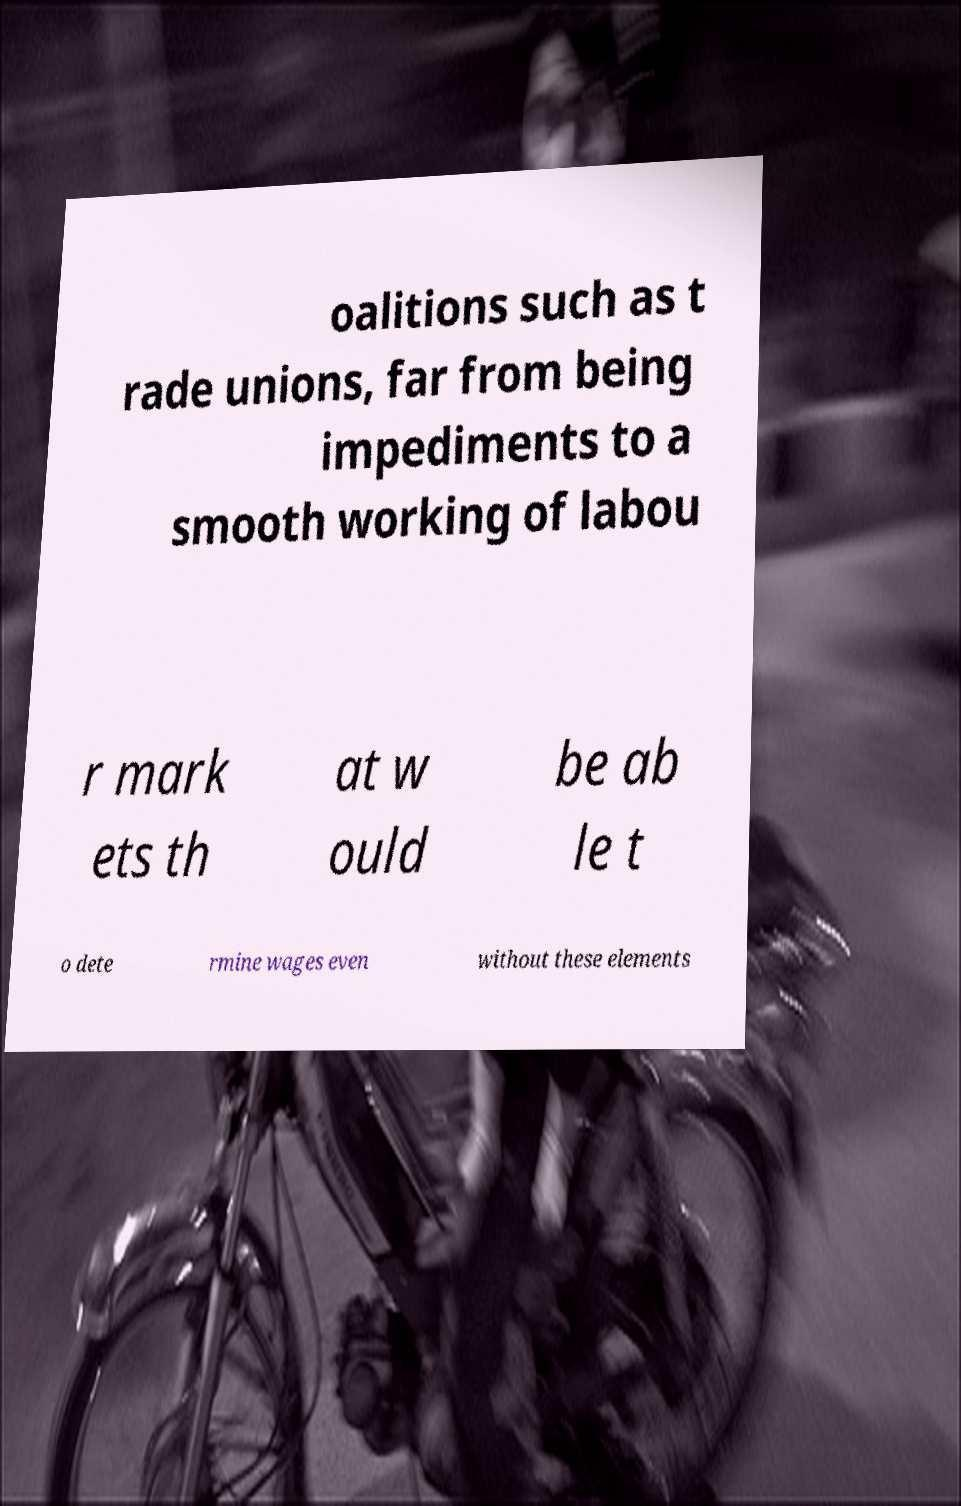Could you assist in decoding the text presented in this image and type it out clearly? oalitions such as t rade unions, far from being impediments to a smooth working of labou r mark ets th at w ould be ab le t o dete rmine wages even without these elements 